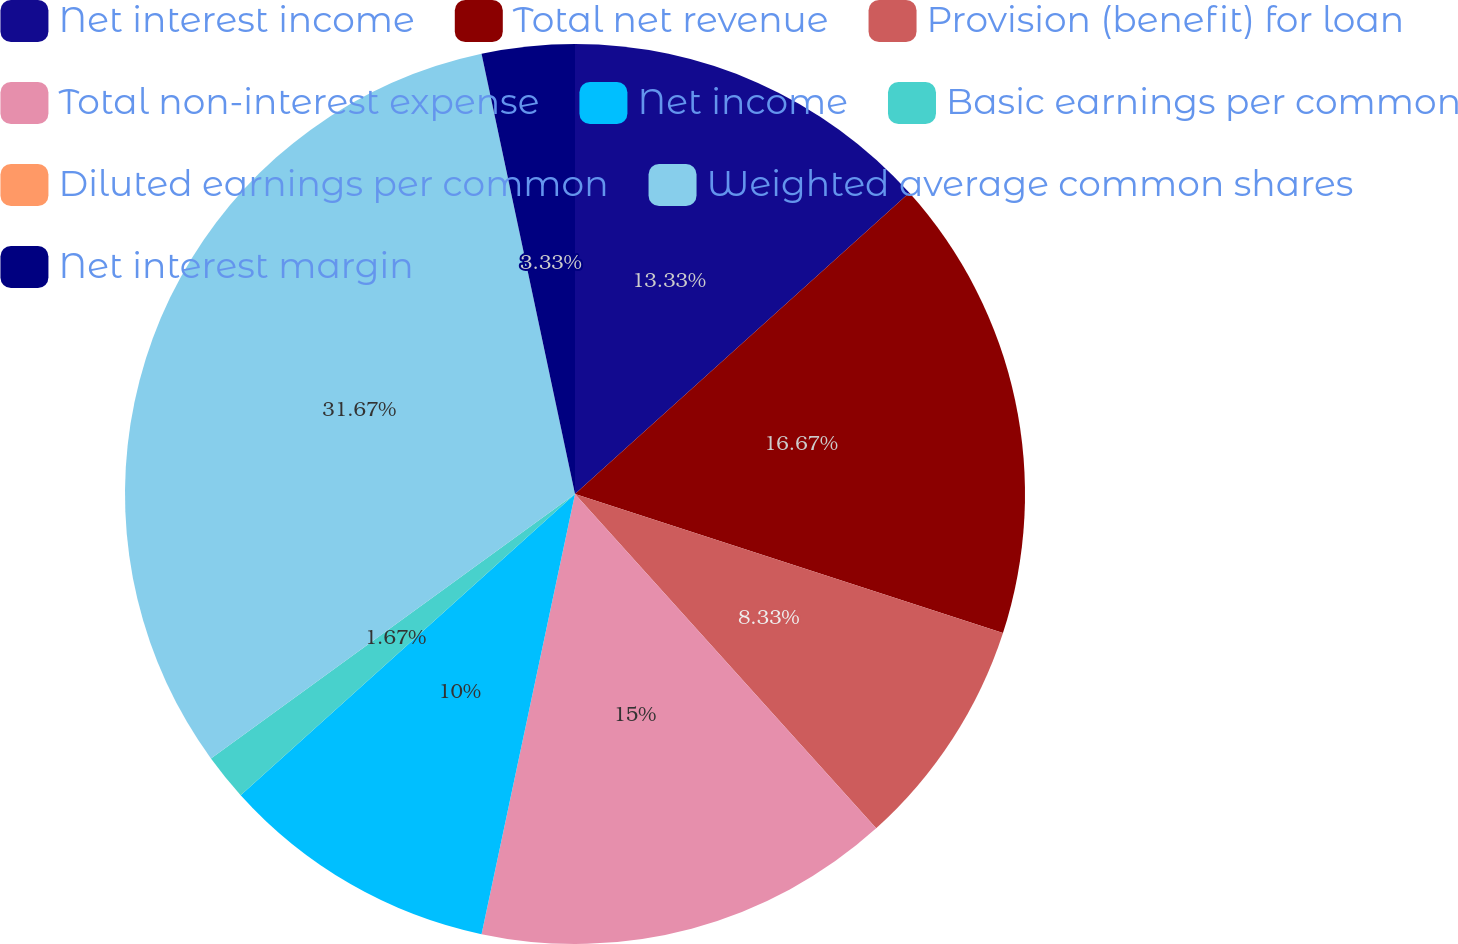<chart> <loc_0><loc_0><loc_500><loc_500><pie_chart><fcel>Net interest income<fcel>Total net revenue<fcel>Provision (benefit) for loan<fcel>Total non-interest expense<fcel>Net income<fcel>Basic earnings per common<fcel>Diluted earnings per common<fcel>Weighted average common shares<fcel>Net interest margin<nl><fcel>13.33%<fcel>16.67%<fcel>8.33%<fcel>15.0%<fcel>10.0%<fcel>1.67%<fcel>0.0%<fcel>31.67%<fcel>3.33%<nl></chart> 